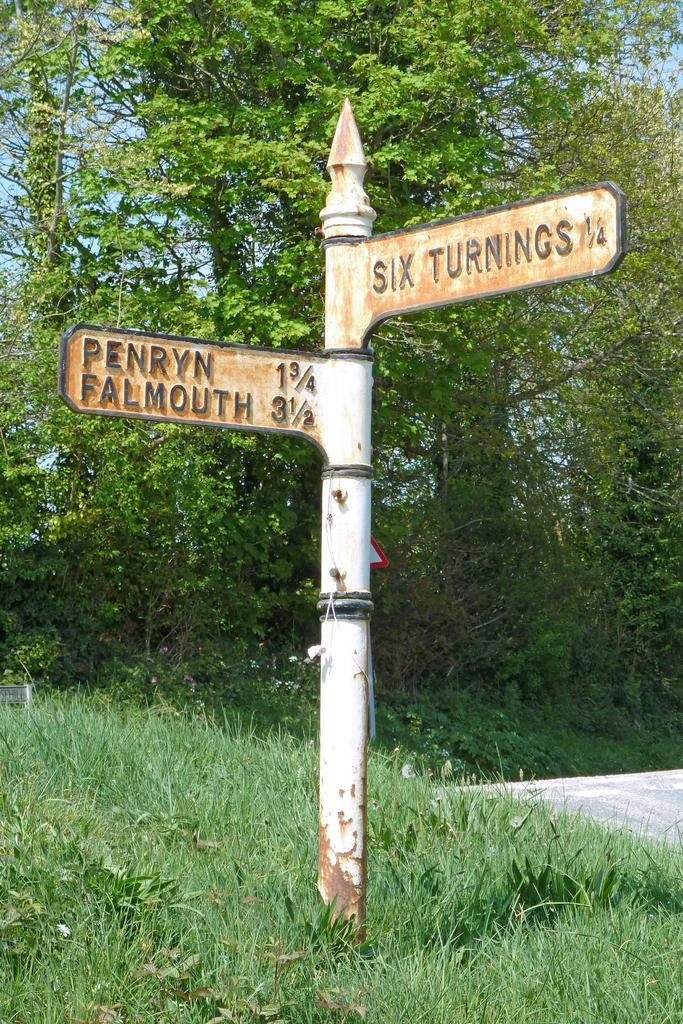What is on the pole in the image? There is a street sign on a pole in the image. What type of vegetation can be seen in the image? There is grass and trees visible in the image. What is visible in the background of the image? The sky is visible in the image. How many sisters are holding hands in the image? There are no sisters present in the image. What type of plants are growing on the street sign? There are no plants growing on the street sign in the image. 